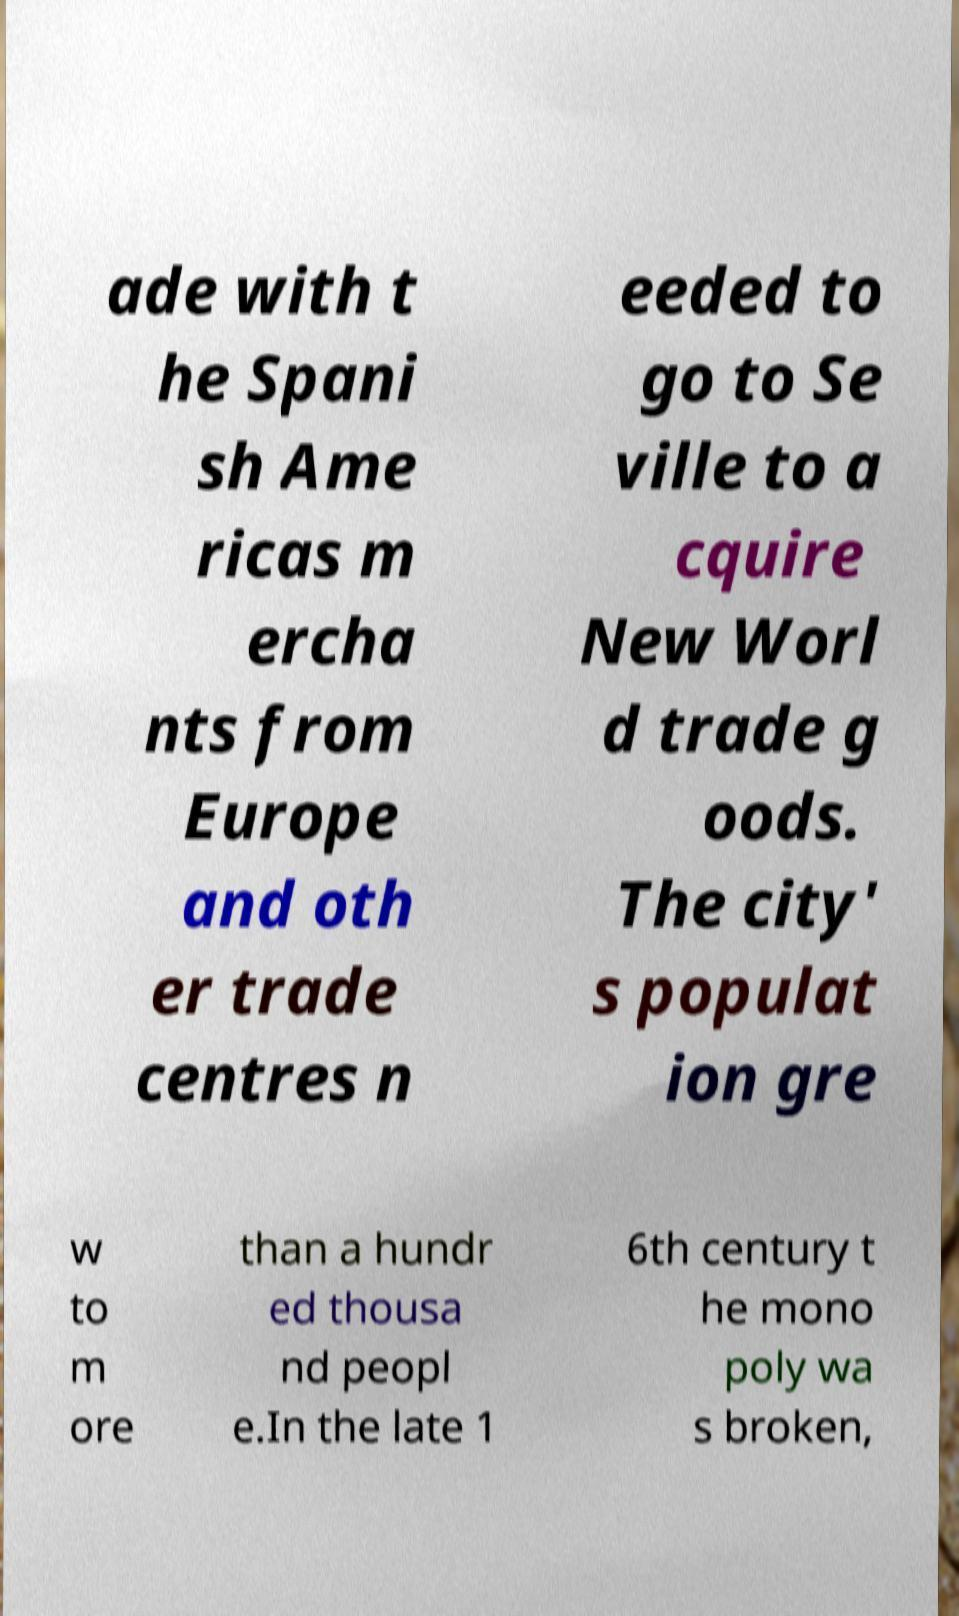What messages or text are displayed in this image? I need them in a readable, typed format. ade with t he Spani sh Ame ricas m ercha nts from Europe and oth er trade centres n eeded to go to Se ville to a cquire New Worl d trade g oods. The city' s populat ion gre w to m ore than a hundr ed thousa nd peopl e.In the late 1 6th century t he mono poly wa s broken, 